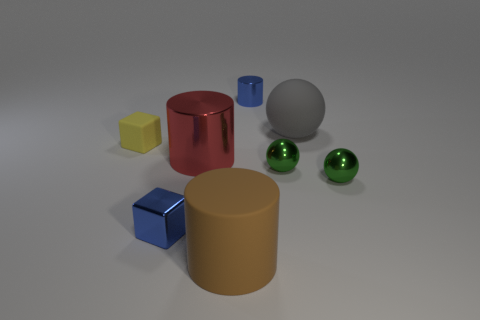Is there a rubber thing of the same color as the matte cube?
Ensure brevity in your answer.  No. Is the number of tiny things less than the number of large brown spheres?
Give a very brief answer. No. How many things are brown matte cylinders or big cylinders to the left of the large brown cylinder?
Ensure brevity in your answer.  2. Are there any other brown cylinders that have the same material as the large brown cylinder?
Your response must be concise. No. What material is the brown thing that is the same size as the red metal cylinder?
Make the answer very short. Rubber. What is the cube that is behind the tiny blue object in front of the small rubber thing made of?
Offer a terse response. Rubber. There is a big thing to the right of the blue metal cylinder; is its shape the same as the big shiny object?
Make the answer very short. No. What color is the big cylinder that is made of the same material as the large sphere?
Give a very brief answer. Brown. There is a sphere that is behind the yellow object; what material is it?
Ensure brevity in your answer.  Rubber. There is a large red shiny thing; does it have the same shape as the blue metallic object behind the large metallic thing?
Give a very brief answer. Yes. 